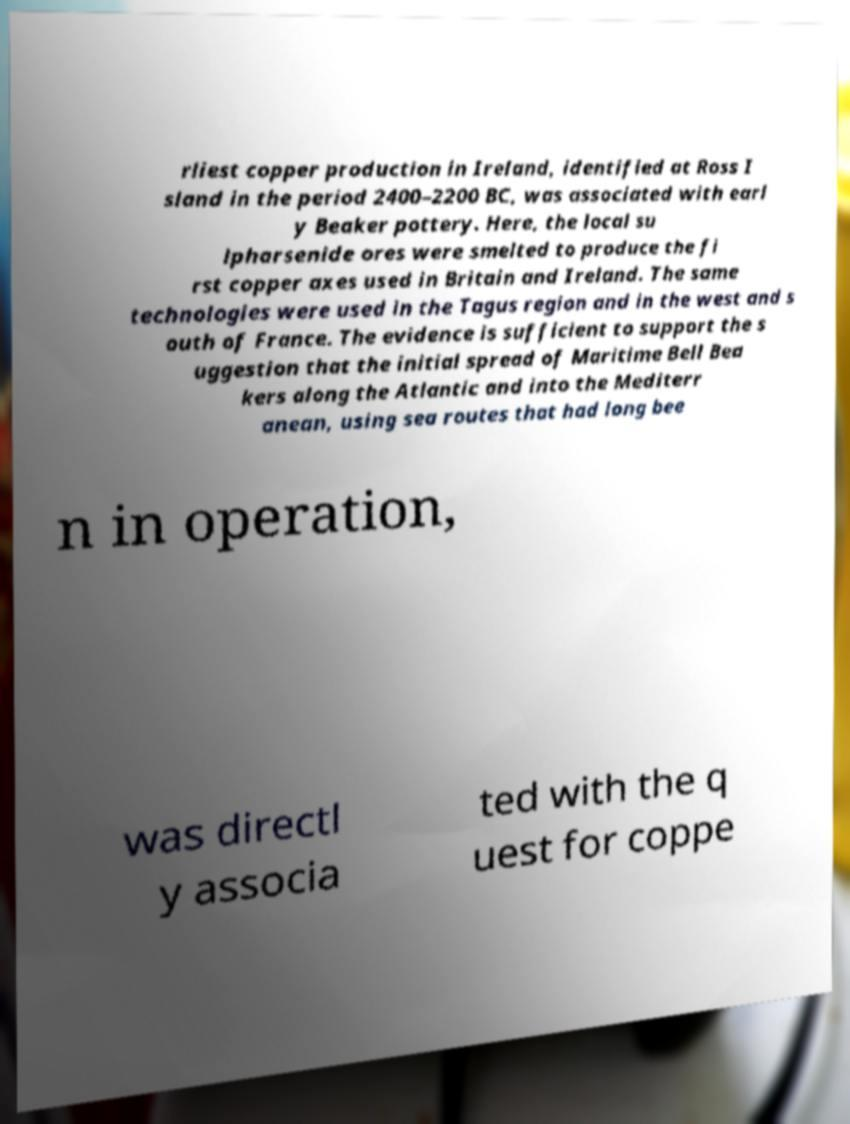There's text embedded in this image that I need extracted. Can you transcribe it verbatim? rliest copper production in Ireland, identified at Ross I sland in the period 2400–2200 BC, was associated with earl y Beaker pottery. Here, the local su lpharsenide ores were smelted to produce the fi rst copper axes used in Britain and Ireland. The same technologies were used in the Tagus region and in the west and s outh of France. The evidence is sufficient to support the s uggestion that the initial spread of Maritime Bell Bea kers along the Atlantic and into the Mediterr anean, using sea routes that had long bee n in operation, was directl y associa ted with the q uest for coppe 